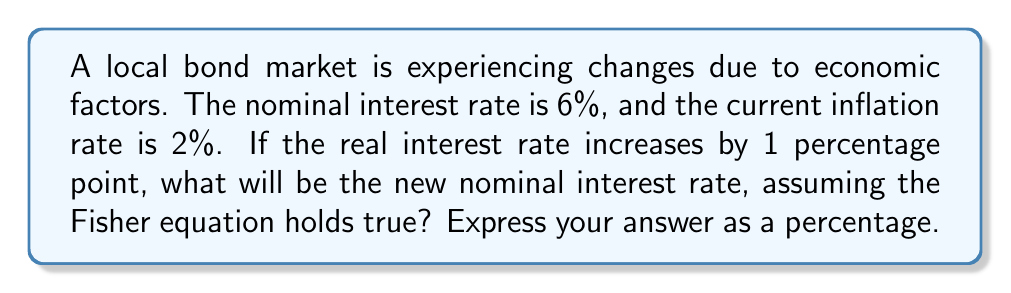Show me your answer to this math problem. Let's approach this step-by-step using the Fisher equation:

1) The Fisher equation states that:
   $$(1 + i) = (1 + r)(1 + \pi)$$
   Where:
   $i$ = nominal interest rate
   $r$ = real interest rate
   $\pi$ = inflation rate

2) We're given:
   Nominal interest rate $(i) = 6\% = 0.06$
   Inflation rate $(\pi) = 2\% = 0.02$

3) Let's find the current real interest rate using the Fisher equation:
   $$(1 + 0.06) = (1 + r)(1 + 0.02)$$
   $$1.06 = (1 + r)(1.02)$$
   $$1.06 \div 1.02 = 1 + r$$
   $$1.0392156862745098 = 1 + r$$
   $$r \approx 0.0392 \text{ or } 3.92\%$$

4) The question states that the real interest rate increases by 1 percentage point:
   New real interest rate = $3.92\% + 1\% = 4.92\% = 0.0492$

5) Now, let's use the Fisher equation again to find the new nominal interest rate:
   $$(1 + i_{new}) = (1 + 0.0492)(1 + 0.02)$$
   $$(1 + i_{new}) = (1.0492)(1.02)$$
   $$(1 + i_{new}) = 1.070184$$
   $$i_{new} = 0.070184$$

6) Converting to a percentage:
   $$i_{new} \approx 7.02\%$$
Answer: 7.02% 